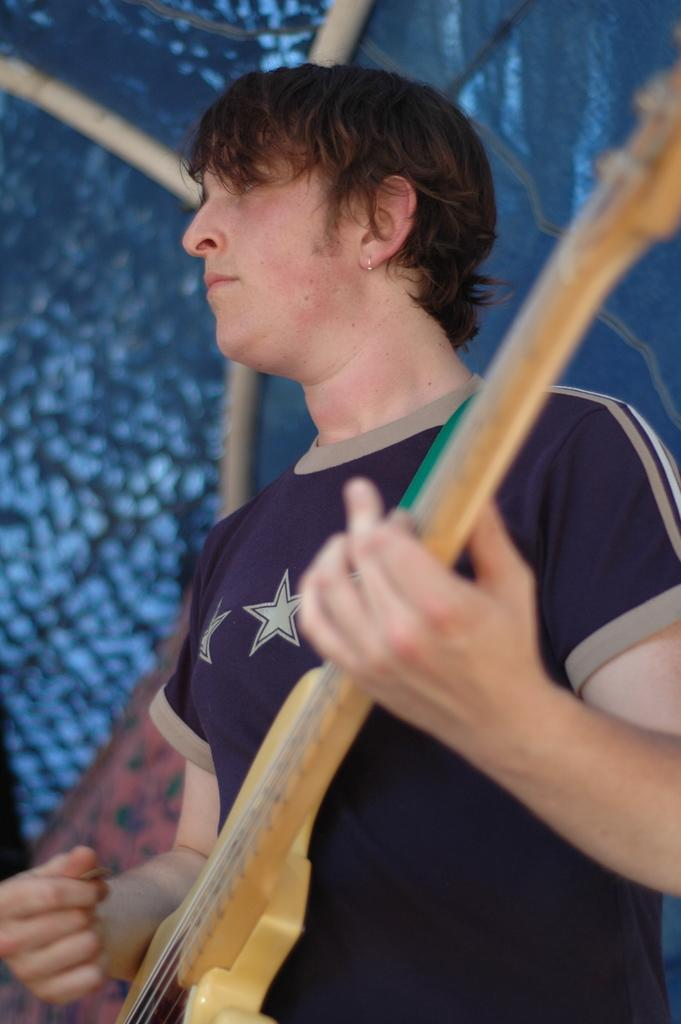What is the person in the image doing? The person is holding a guitar. What position is the person in? The person is standing. What can be seen behind the person? There is a pole visible behind the person. What type of flesh can be seen growing on the guitar in the image? There is no flesh growing on the guitar in the image; it is a musical instrument made of materials like wood or metal. 